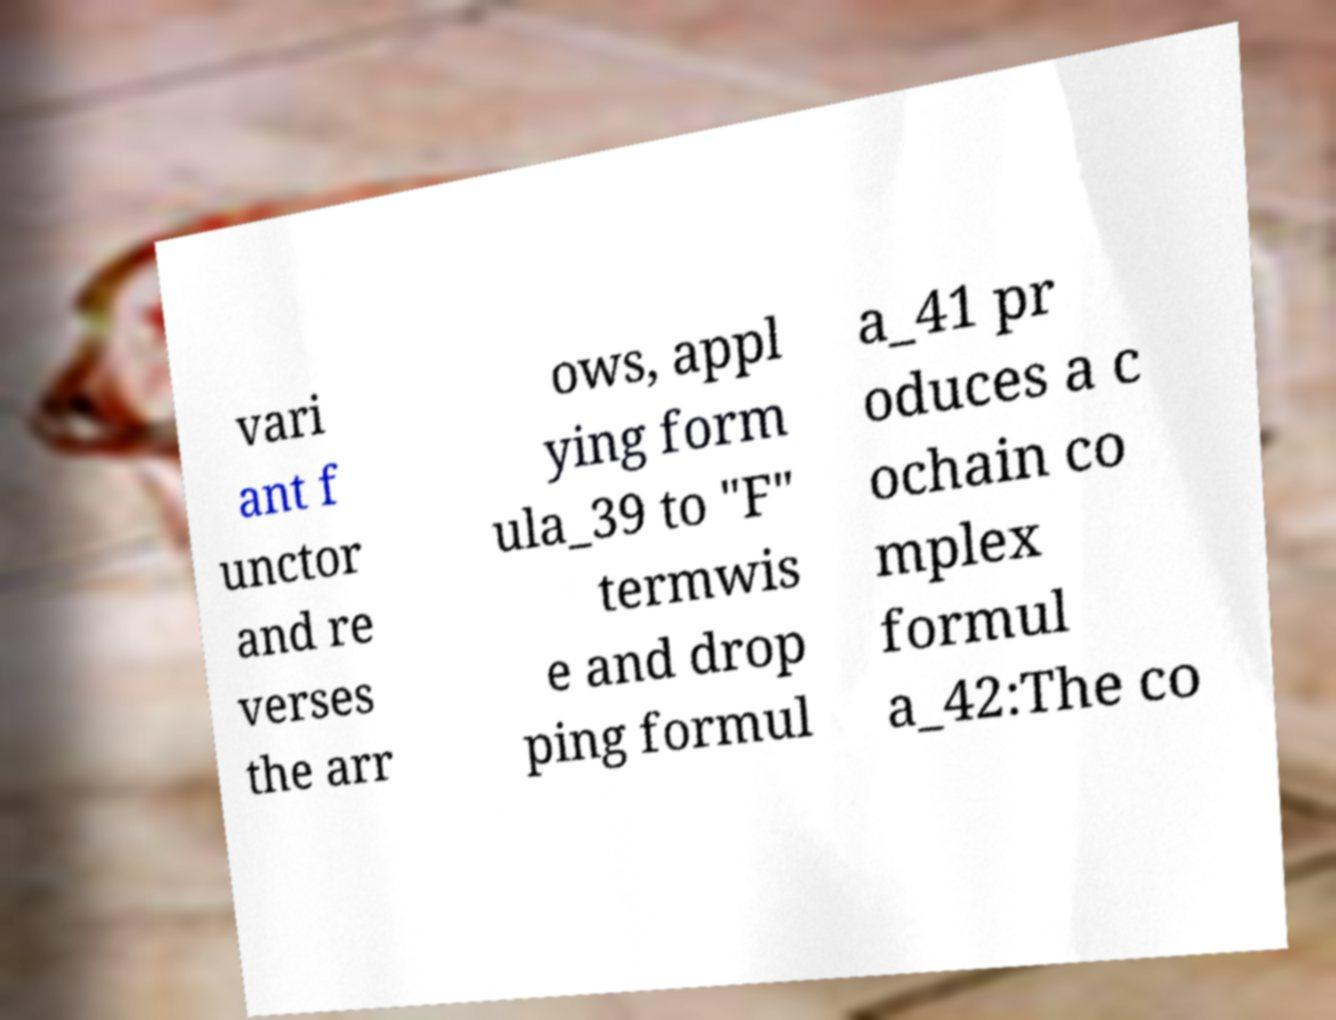What messages or text are displayed in this image? I need them in a readable, typed format. vari ant f unctor and re verses the arr ows, appl ying form ula_39 to "F" termwis e and drop ping formul a_41 pr oduces a c ochain co mplex formul a_42:The co 